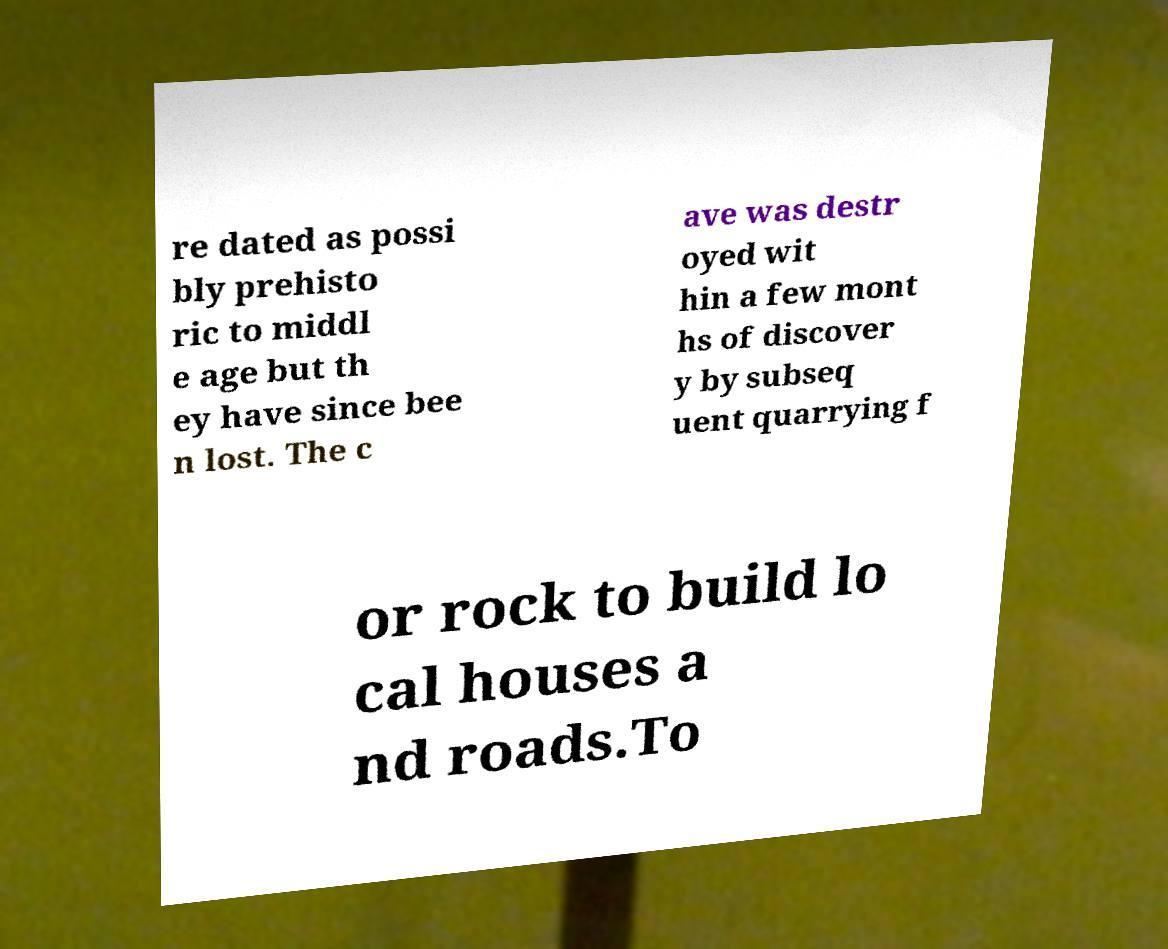Can you read and provide the text displayed in the image?This photo seems to have some interesting text. Can you extract and type it out for me? re dated as possi bly prehisto ric to middl e age but th ey have since bee n lost. The c ave was destr oyed wit hin a few mont hs of discover y by subseq uent quarrying f or rock to build lo cal houses a nd roads.To 